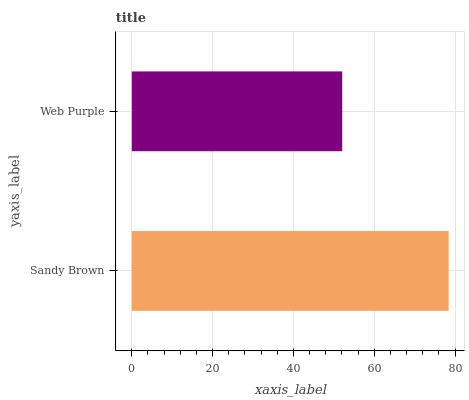Is Web Purple the minimum?
Answer yes or no. Yes. Is Sandy Brown the maximum?
Answer yes or no. Yes. Is Web Purple the maximum?
Answer yes or no. No. Is Sandy Brown greater than Web Purple?
Answer yes or no. Yes. Is Web Purple less than Sandy Brown?
Answer yes or no. Yes. Is Web Purple greater than Sandy Brown?
Answer yes or no. No. Is Sandy Brown less than Web Purple?
Answer yes or no. No. Is Sandy Brown the high median?
Answer yes or no. Yes. Is Web Purple the low median?
Answer yes or no. Yes. Is Web Purple the high median?
Answer yes or no. No. Is Sandy Brown the low median?
Answer yes or no. No. 